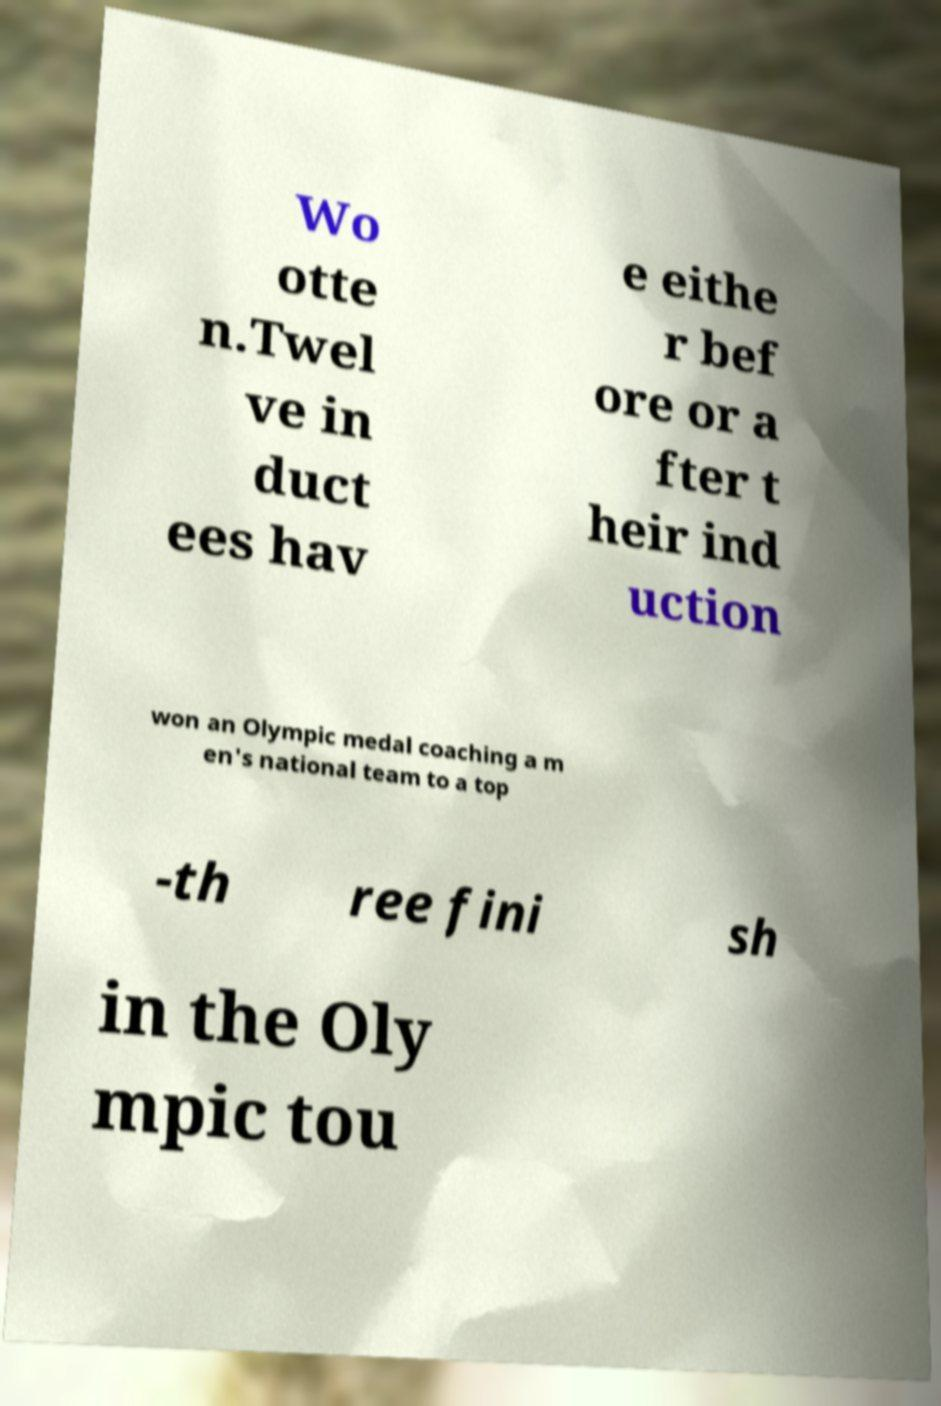For documentation purposes, I need the text within this image transcribed. Could you provide that? Wo otte n.Twel ve in duct ees hav e eithe r bef ore or a fter t heir ind uction won an Olympic medal coaching a m en's national team to a top -th ree fini sh in the Oly mpic tou 